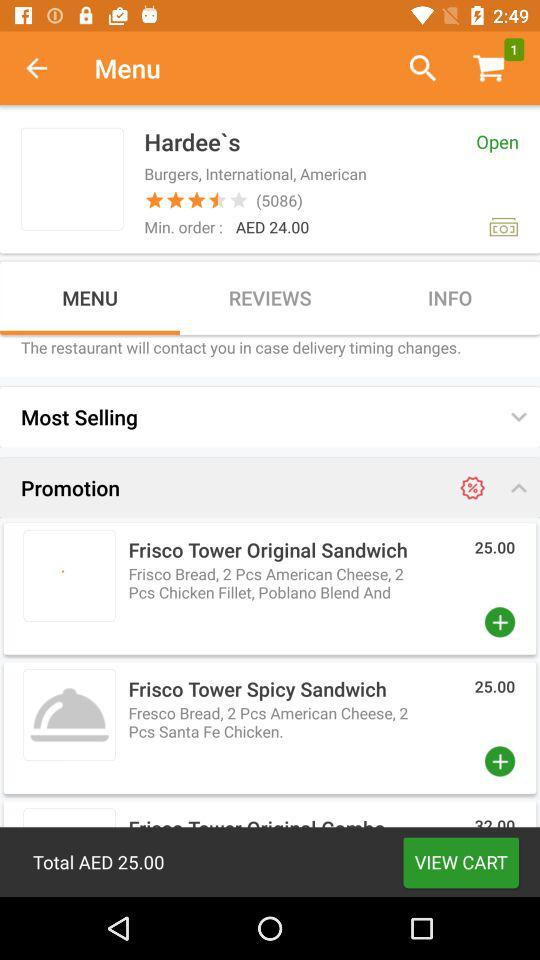How many stars are given to Hardee's? The stars given to Hardee's are 3.5. 